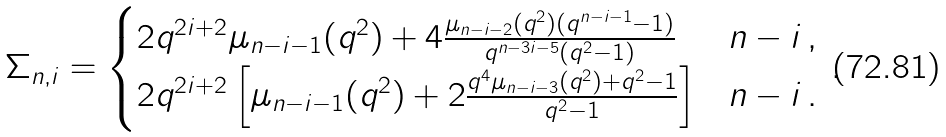<formula> <loc_0><loc_0><loc_500><loc_500>\Sigma _ { n , i } = \begin{cases} 2 q ^ { 2 i + 2 } \mu _ { n - i - 1 } ( q ^ { 2 } ) + 4 \frac { \mu _ { n - i - 2 } ( q ^ { 2 } ) ( q ^ { n - i - 1 } - 1 ) } { q ^ { n - 3 i - 5 } ( q ^ { 2 } - 1 ) } & n - i \, , \\ 2 q ^ { 2 i + 2 } \left [ \mu _ { n - i - 1 } ( q ^ { 2 } ) + 2 \frac { q ^ { 4 } \mu _ { n - i - 3 } ( q ^ { 2 } ) + q ^ { 2 } - 1 } { q ^ { 2 } - 1 } \right ] & n - i \, . \end{cases} \, .</formula> 